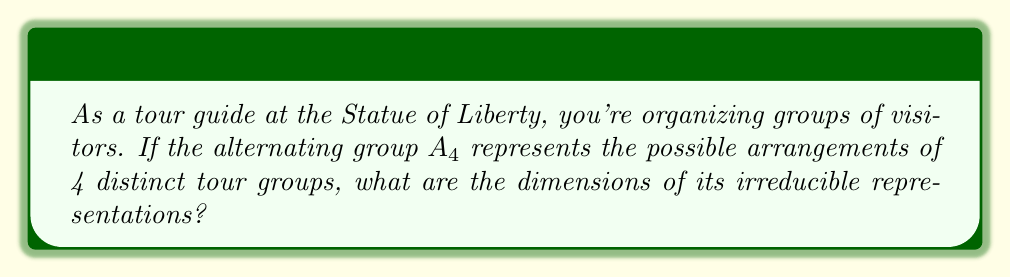Help me with this question. To find the dimensions of the irreducible representations of $A_4$, we'll follow these steps:

1) First, recall that the sum of the squares of the dimensions of irreducible representations equals the order of the group. For $A_4$, $|A_4| = 12$.

2) Next, we need to find the conjugacy classes of $A_4$:
   - Identity: $(1)$
   - 3-cycles: $(123)$, $(132)$, $(124)$, $(142)$, $(134)$, $(143)$, $(234)$, $(243)$
   - Double transpositions: $(12)(34)$, $(13)(24)$, $(14)(23)$

3) The number of irreducible representations is equal to the number of conjugacy classes. Here, we have 4 classes.

4) $A_4$ always has a trivial representation of dimension 1.

5) $A_4$ is not abelian, so it must have at least one representation of dimension greater than 1.

6) Let the dimensions of the irreducible representations be $1, 1, 1, 3$. We can verify:

   $1^2 + 1^2 + 1^2 + 3^2 = 1 + 1 + 1 + 9 = 12 = |A_4|$

7) This satisfies our condition from step 1, and it's the only possible combination given the constraints.

Therefore, the dimensions of the irreducible representations of $A_4$ are 1, 1, 1, and 3.
Answer: 1, 1, 1, 3 